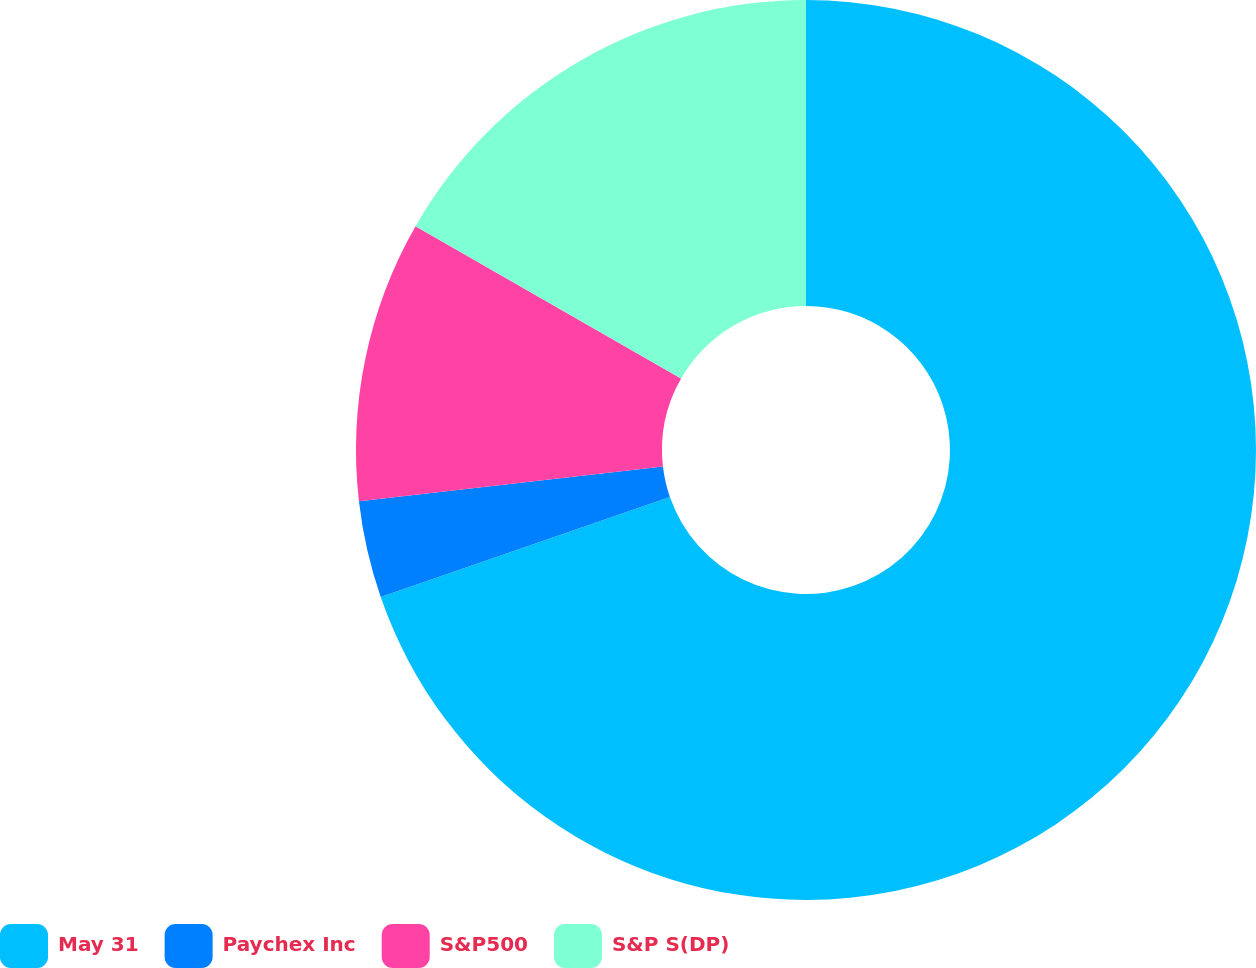Convert chart to OTSL. <chart><loc_0><loc_0><loc_500><loc_500><pie_chart><fcel>May 31<fcel>Paychex Inc<fcel>S&P500<fcel>S&P S(DP)<nl><fcel>69.7%<fcel>3.48%<fcel>10.1%<fcel>16.72%<nl></chart> 